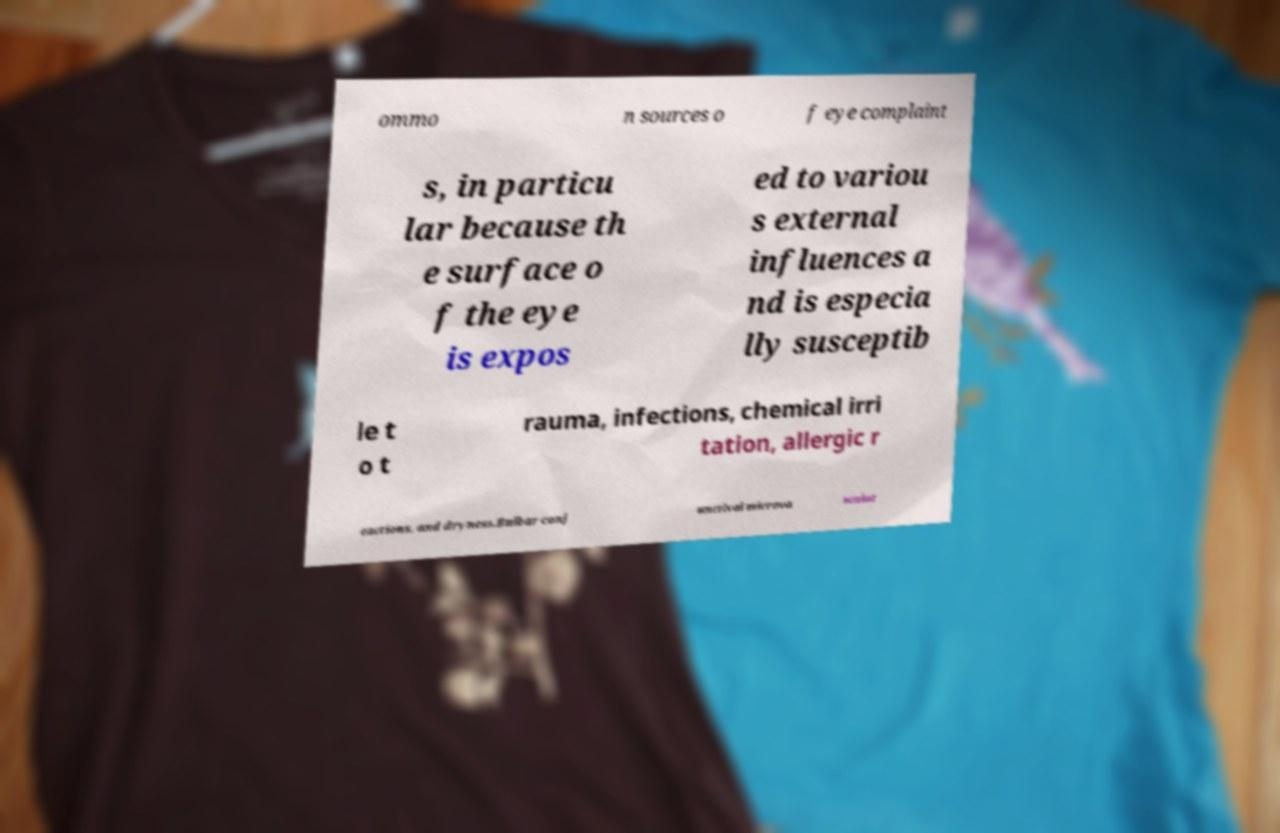Please read and relay the text visible in this image. What does it say? ommo n sources o f eye complaint s, in particu lar because th e surface o f the eye is expos ed to variou s external influences a nd is especia lly susceptib le t o t rauma, infections, chemical irri tation, allergic r eactions, and dryness.Bulbar conj unctival microva sculat 